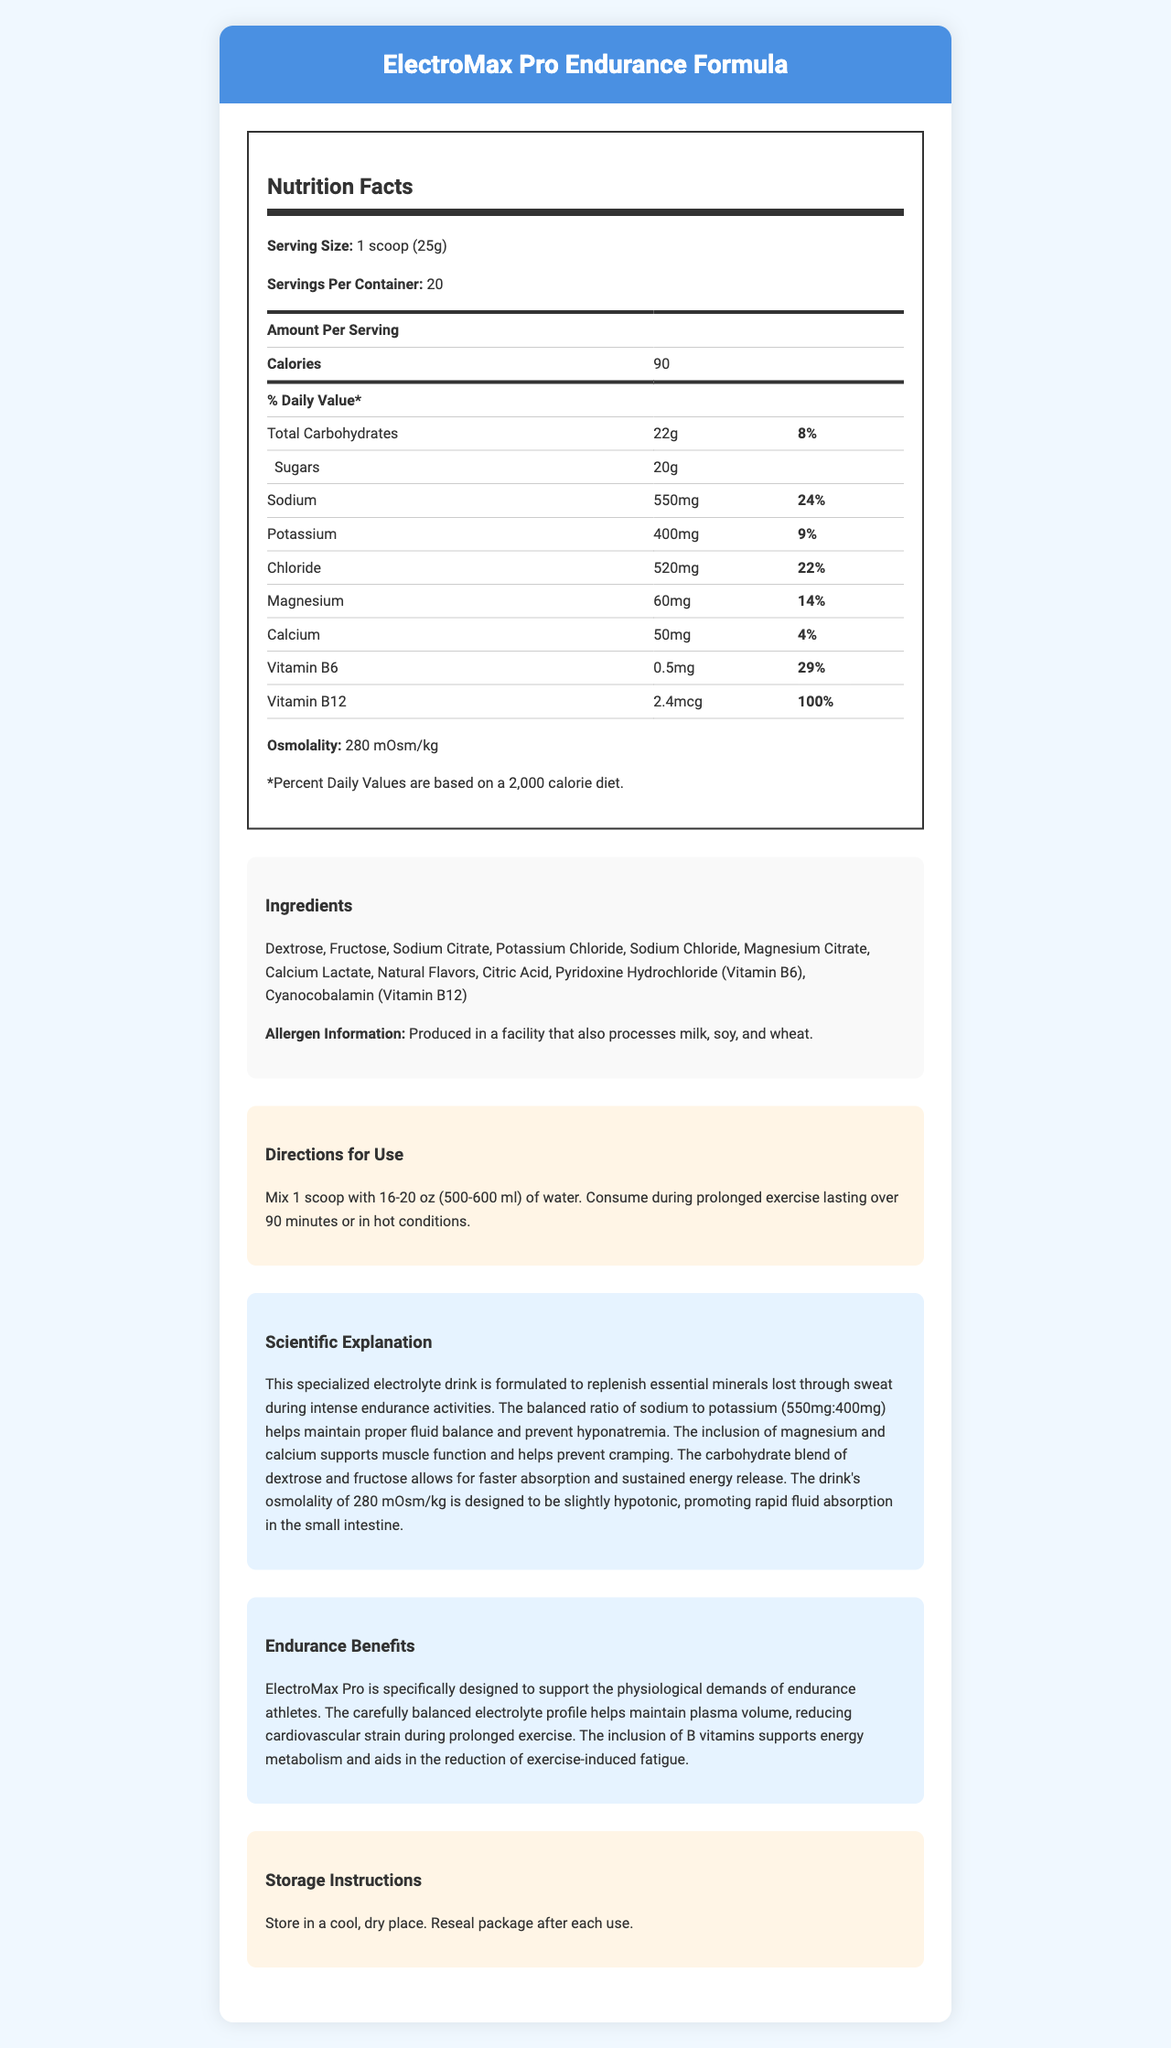how many calories are in a single serving? The document lists "Calories" as 90 per serving.
Answer: 90 calories what is the serving size for ElectroMax Pro Endurance Formula? The document specifies the serving size as "1 scoop (25g)".
Answer: 1 scoop (25g) how much sodium is in each serving? The document shows "Sodium" content as 550mg per serving.
Answer: 550mg how many servings are in one container? The document states that there are 20 servings per container.
Answer: 20 servings what is the osmolality of the drink mix? The document states the osmolality as 280 mOsm/kg.
Answer: 280 mOsm/kg which mineral has the highest content per serving?
A. Sodium
B. Potassium
C. Chloride
D. Calcium The document shows "Sodium" content as 550mg, which is higher than Potassium (400mg), Chloride (520mg), and Calcium (50mg).
Answer: A. Sodium what percentage of the daily value of Vitamin B12 does one serving provide?
A. 29%
B. 100%
C. 9%
D. 14% The document indicates that the Vitamin B12 content per serving provides 100% of the daily value.
Answer: B. 100% does this product contain protein? The document does not list any protein content in the nutrition facts.
Answer: No is this product suitable for someone with a milk allergy? The allergen information states it is produced in a facility that processes milk, soy, and wheat.
Answer: No summarize the main benefits of ElectroMax Pro Endurance Formula. The document outlines these benefits in the sections on scientific explanation and endurance benefits.
Answer: The drink is designed to support endurance athletes by replenishing lost minerals, preventing muscle cramps, and maintaining fluid balance. It contains a balanced ratio of sodium and potassium, includes magnesium and calcium for muscle support, and B vitamins for energy metabolism. does this product have more potassium or chloride? The document lists chloride content as 520mg and potassium as 400mg per serving.
Answer: Chloride what quantity of water should be mixed with one scoop of this drink mix? The directions specify to mix 1 scoop with 16-20 oz (500-600 ml) of water.
Answer: 16-20 oz (500-600 ml) what is the main carbohydrate type in this drink mix? The ingredients list dextrose and fructose as the main carbohydrate sources.
Answer: Dextrose and Fructose what purpose do B vitamins serve in this drink? The document states that the inclusion of B vitamins supports energy metabolism and aids in reducing fatigue.
Answer: To support energy metabolism and reduce exercise-induced fatigue why is osmolality important for this drink mix? The scientific explanation section mentions that the osmolality of 280 mOsm/kg is designed to be slightly hypotonic, which promotes rapid fluid absorption.
Answer: It promotes rapid fluid absorption in the small intestine. how is fluid balance maintained by this drink? The document explains that the balanced ratio of sodium to potassium helps maintain proper fluid balance and prevent hyponatremia.
Answer: Through a balanced ratio of sodium to potassium (550mg:400mg) how should this product be stored for best results? The storage instructions specify these conditions for optimal storage.
Answer: Store in a cool, dry place. Reseal package after each use. what scientific principle is the drink mix based on? The scientific explanation outlines that the product is formulated based on the principle of replenishing essential minerals to support endurance activities.
Answer: Replenishing essential minerals lost through sweat and maintaining fluid balance what flavor is the drink mix? The document does not provide specific information about the flavor of the drink mix.
Answer: Cannot be determined 